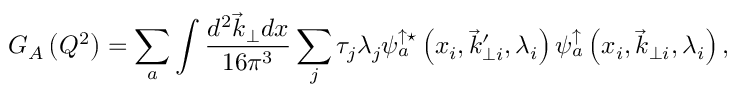<formula> <loc_0><loc_0><loc_500><loc_500>G _ { A } \left ( Q ^ { 2 } \right ) = \sum _ { a } \int \frac { d ^ { 2 } \vec { k } _ { \perp } d x } { 1 6 \pi ^ { 3 } } \sum _ { j } \tau _ { j } \lambda _ { j } \psi _ { a } ^ { \uparrow ^ { * } } \left ( x _ { i } , \vec { k } _ { \perp i } ^ { \prime } , \lambda _ { i } \right ) \psi _ { a } ^ { \uparrow } \left ( x _ { i } , \vec { k } _ { \perp i } , \lambda _ { i } \right ) ,</formula> 